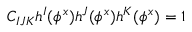<formula> <loc_0><loc_0><loc_500><loc_500>C _ { I J K } h ^ { I } ( \phi ^ { x } ) h ^ { J } ( \phi ^ { x } ) h ^ { K } ( \phi ^ { x } ) = 1</formula> 